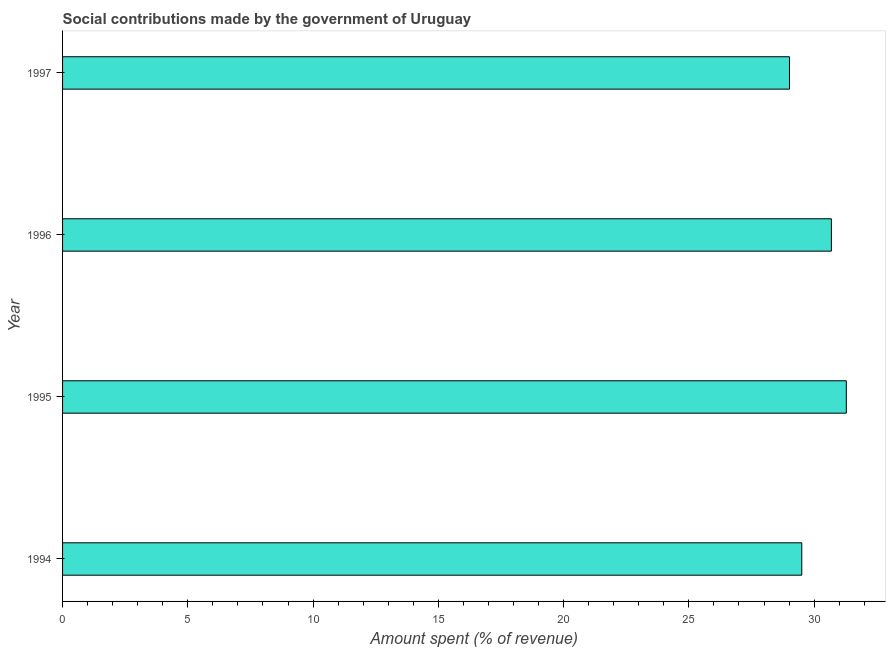What is the title of the graph?
Give a very brief answer. Social contributions made by the government of Uruguay. What is the label or title of the X-axis?
Offer a very short reply. Amount spent (% of revenue). What is the label or title of the Y-axis?
Your answer should be very brief. Year. What is the amount spent in making social contributions in 1995?
Make the answer very short. 31.28. Across all years, what is the maximum amount spent in making social contributions?
Keep it short and to the point. 31.28. Across all years, what is the minimum amount spent in making social contributions?
Your answer should be very brief. 29.02. In which year was the amount spent in making social contributions maximum?
Provide a short and direct response. 1995. What is the sum of the amount spent in making social contributions?
Ensure brevity in your answer.  120.5. What is the difference between the amount spent in making social contributions in 1995 and 1997?
Your response must be concise. 2.27. What is the average amount spent in making social contributions per year?
Provide a succinct answer. 30.12. What is the median amount spent in making social contributions?
Your response must be concise. 30.1. In how many years, is the amount spent in making social contributions greater than 14 %?
Make the answer very short. 4. Do a majority of the years between 1995 and 1997 (inclusive) have amount spent in making social contributions greater than 5 %?
Your response must be concise. Yes. What is the ratio of the amount spent in making social contributions in 1994 to that in 1997?
Give a very brief answer. 1.02. Is the amount spent in making social contributions in 1994 less than that in 1995?
Give a very brief answer. Yes. What is the difference between the highest and the second highest amount spent in making social contributions?
Offer a very short reply. 0.6. Is the sum of the amount spent in making social contributions in 1994 and 1995 greater than the maximum amount spent in making social contributions across all years?
Provide a short and direct response. Yes. What is the difference between the highest and the lowest amount spent in making social contributions?
Make the answer very short. 2.27. How many bars are there?
Give a very brief answer. 4. Are all the bars in the graph horizontal?
Keep it short and to the point. Yes. What is the difference between two consecutive major ticks on the X-axis?
Ensure brevity in your answer.  5. Are the values on the major ticks of X-axis written in scientific E-notation?
Ensure brevity in your answer.  No. What is the Amount spent (% of revenue) of 1994?
Ensure brevity in your answer.  29.51. What is the Amount spent (% of revenue) of 1995?
Offer a very short reply. 31.28. What is the Amount spent (% of revenue) of 1996?
Keep it short and to the point. 30.69. What is the Amount spent (% of revenue) in 1997?
Keep it short and to the point. 29.02. What is the difference between the Amount spent (% of revenue) in 1994 and 1995?
Give a very brief answer. -1.78. What is the difference between the Amount spent (% of revenue) in 1994 and 1996?
Provide a short and direct response. -1.18. What is the difference between the Amount spent (% of revenue) in 1994 and 1997?
Make the answer very short. 0.49. What is the difference between the Amount spent (% of revenue) in 1995 and 1996?
Offer a very short reply. 0.6. What is the difference between the Amount spent (% of revenue) in 1995 and 1997?
Make the answer very short. 2.27. What is the difference between the Amount spent (% of revenue) in 1996 and 1997?
Make the answer very short. 1.67. What is the ratio of the Amount spent (% of revenue) in 1994 to that in 1995?
Provide a succinct answer. 0.94. What is the ratio of the Amount spent (% of revenue) in 1994 to that in 1997?
Your response must be concise. 1.02. What is the ratio of the Amount spent (% of revenue) in 1995 to that in 1997?
Make the answer very short. 1.08. What is the ratio of the Amount spent (% of revenue) in 1996 to that in 1997?
Ensure brevity in your answer.  1.06. 